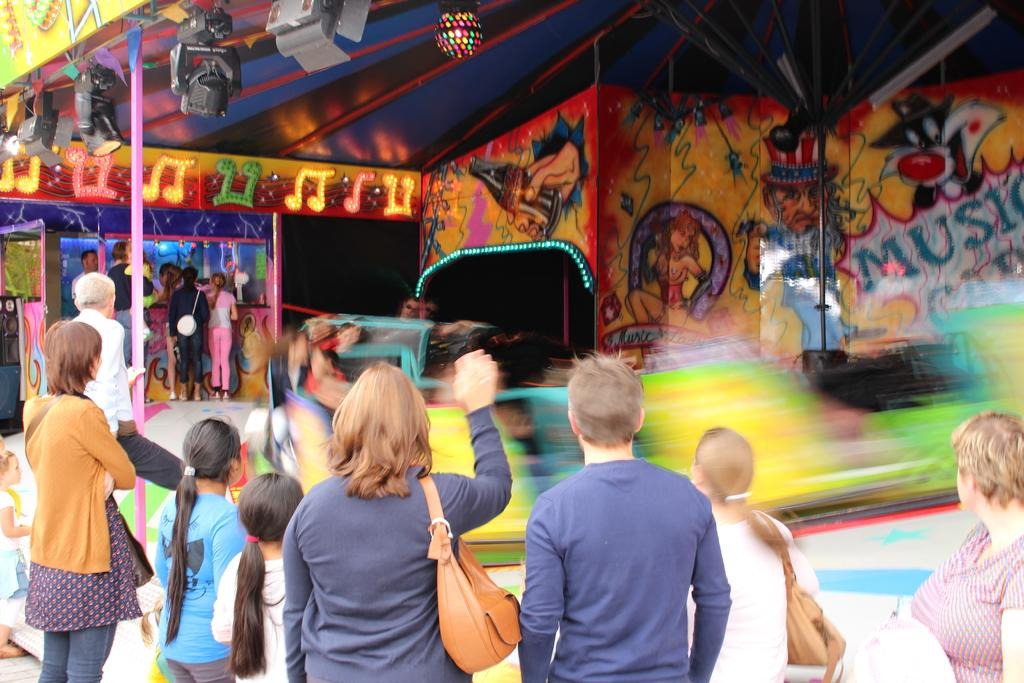What is happening in the image? There is a group of people standing in the image. What can be seen in the background of the image? There are stalls, lights, cameras, and a wall with multiple colors in the background of the image. What type of caption can be seen on the wall in the image? There is no caption visible on the wall in the image; it is a wall with multiple colors. Can you hear the horn of a vehicle in the image? There is no sound present in the image, so it is not possible to determine if a horn can be heard. 